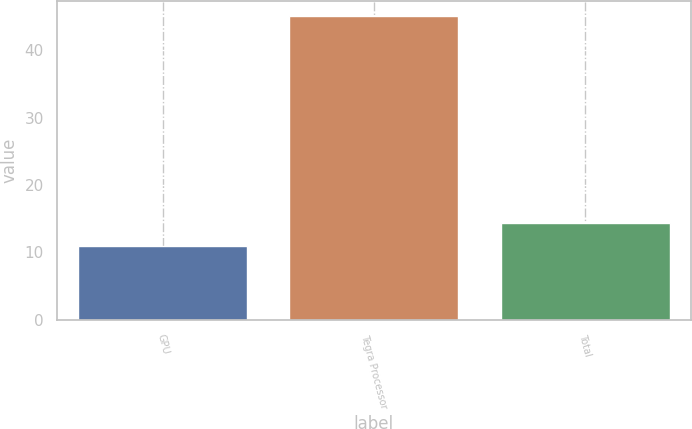Convert chart. <chart><loc_0><loc_0><loc_500><loc_500><bar_chart><fcel>GPU<fcel>Tegra Processor<fcel>Total<nl><fcel>11<fcel>45<fcel>14.4<nl></chart> 